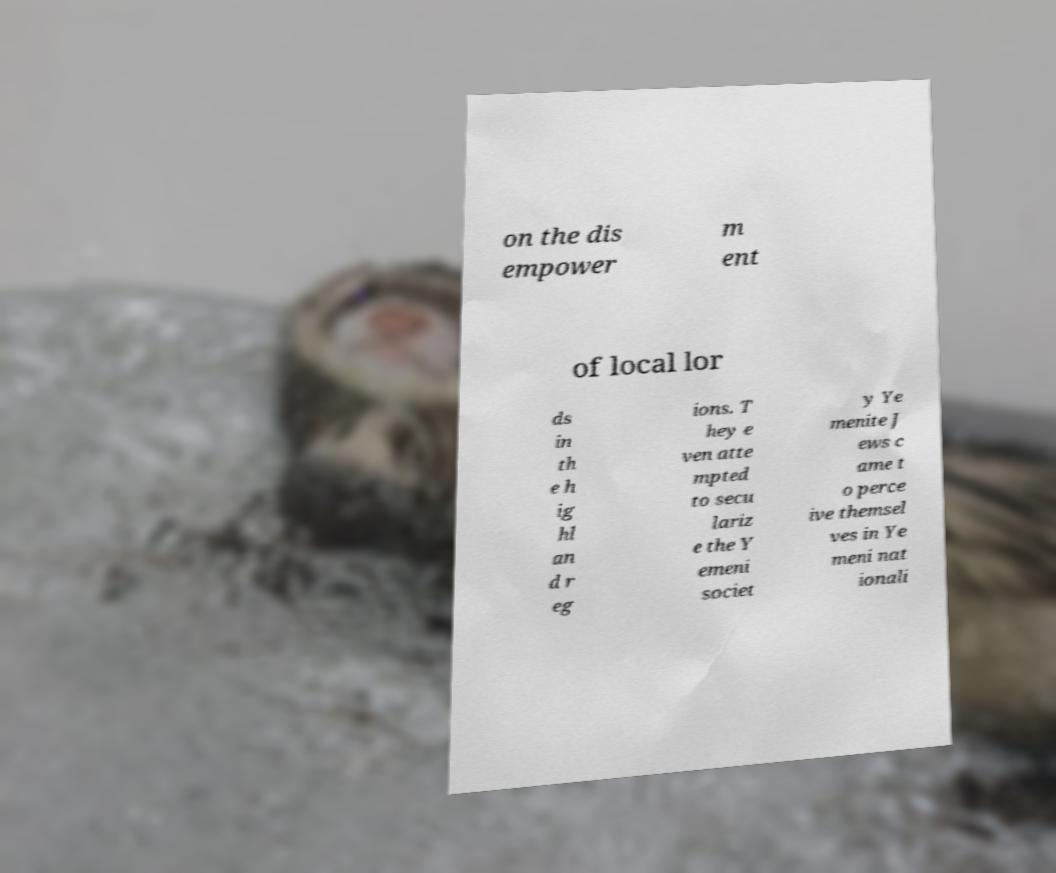What messages or text are displayed in this image? I need them in a readable, typed format. on the dis empower m ent of local lor ds in th e h ig hl an d r eg ions. T hey e ven atte mpted to secu lariz e the Y emeni societ y Ye menite J ews c ame t o perce ive themsel ves in Ye meni nat ionali 